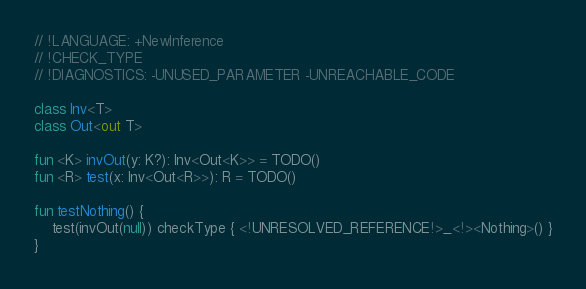<code> <loc_0><loc_0><loc_500><loc_500><_Kotlin_>// !LANGUAGE: +NewInference
// !CHECK_TYPE
// !DIAGNOSTICS: -UNUSED_PARAMETER -UNREACHABLE_CODE

class Inv<T>
class Out<out T>

fun <K> invOut(y: K?): Inv<Out<K>> = TODO()
fun <R> test(x: Inv<Out<R>>): R = TODO()

fun testNothing() {
    test(invOut(null)) checkType { <!UNRESOLVED_REFERENCE!>_<!><Nothing>() }
}
</code> 